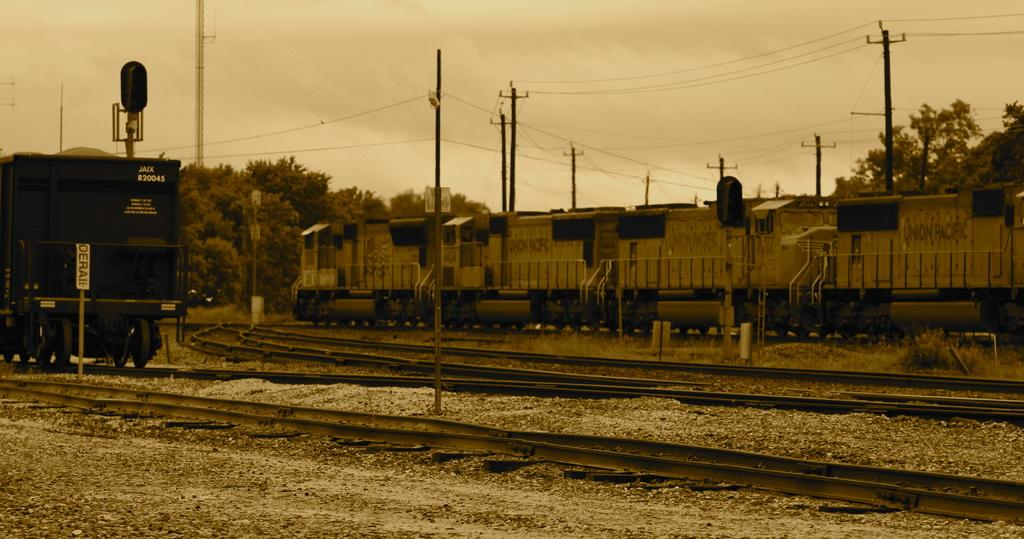What type of transportation infrastructure is visible in the image? There are railway tracks in the image. What mode of transportation can be seen on the railway tracks? There is a train in the image. What can be seen in the background of the image? There are current poles in the background of the image. What type of ship can be seen sailing in the background of the image? There is no ship visible in the image; it features railway tracks, a train, and current poles. What scientific theory is being demonstrated in the image? There is no scientific theory being demonstrated in the image; it simply shows a train on railway tracks with current poles in the background. 